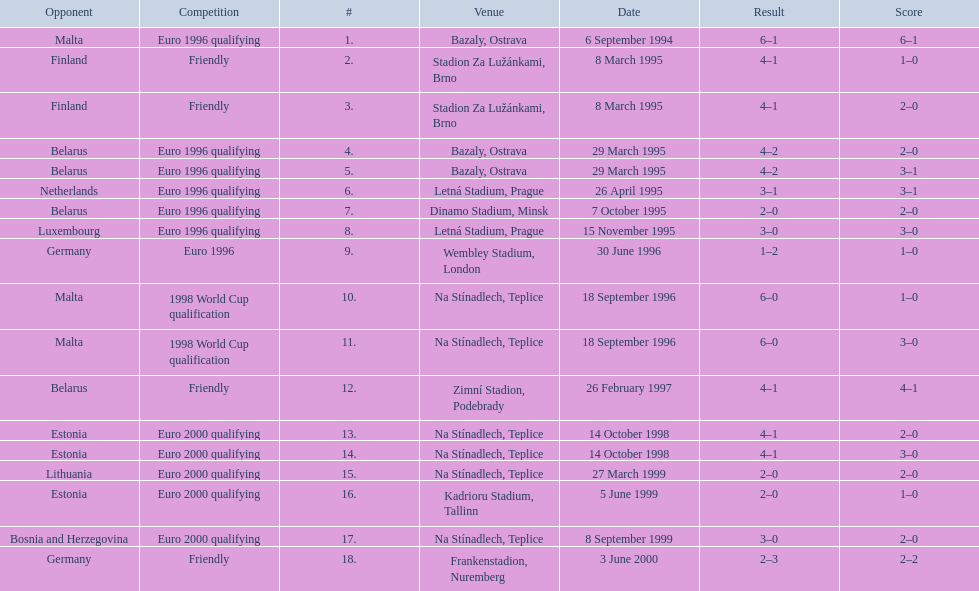Bazaly, ostrava was used on 6 september 1004, but what venue was used on 18 september 1996? Na Stínadlech, Teplice. 